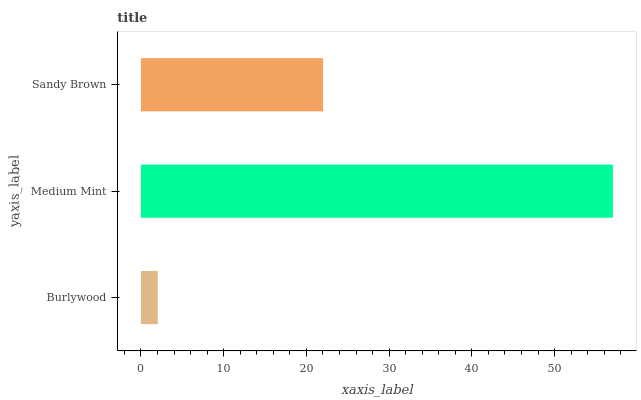Is Burlywood the minimum?
Answer yes or no. Yes. Is Medium Mint the maximum?
Answer yes or no. Yes. Is Sandy Brown the minimum?
Answer yes or no. No. Is Sandy Brown the maximum?
Answer yes or no. No. Is Medium Mint greater than Sandy Brown?
Answer yes or no. Yes. Is Sandy Brown less than Medium Mint?
Answer yes or no. Yes. Is Sandy Brown greater than Medium Mint?
Answer yes or no. No. Is Medium Mint less than Sandy Brown?
Answer yes or no. No. Is Sandy Brown the high median?
Answer yes or no. Yes. Is Sandy Brown the low median?
Answer yes or no. Yes. Is Burlywood the high median?
Answer yes or no. No. Is Medium Mint the low median?
Answer yes or no. No. 